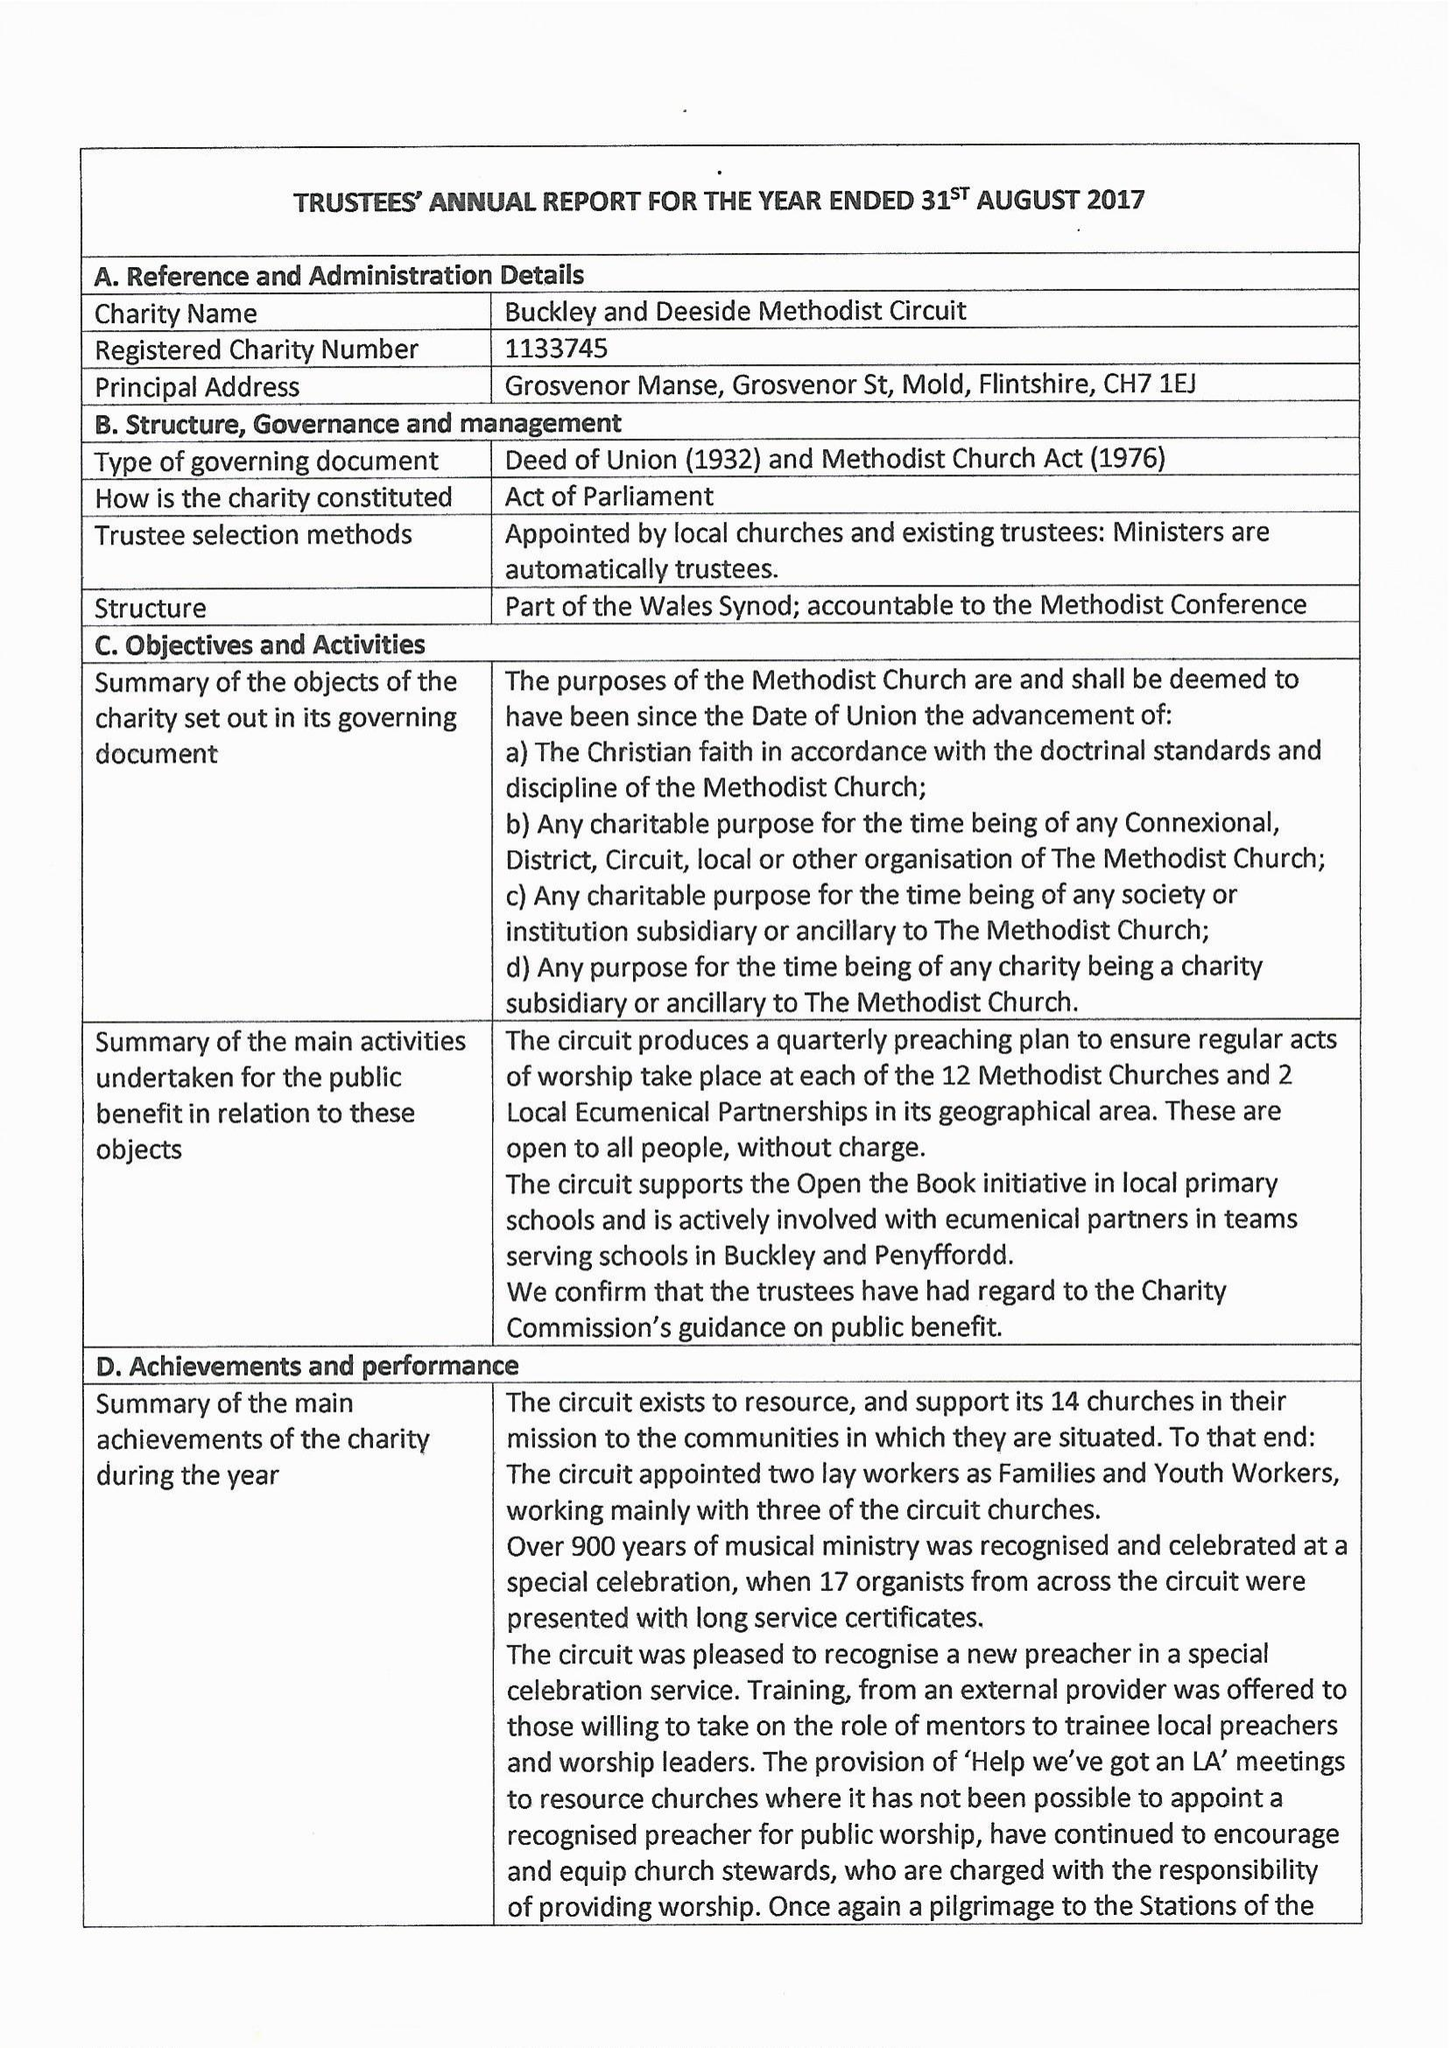What is the value for the address__postcode?
Answer the question using a single word or phrase. CH7 1EJ 